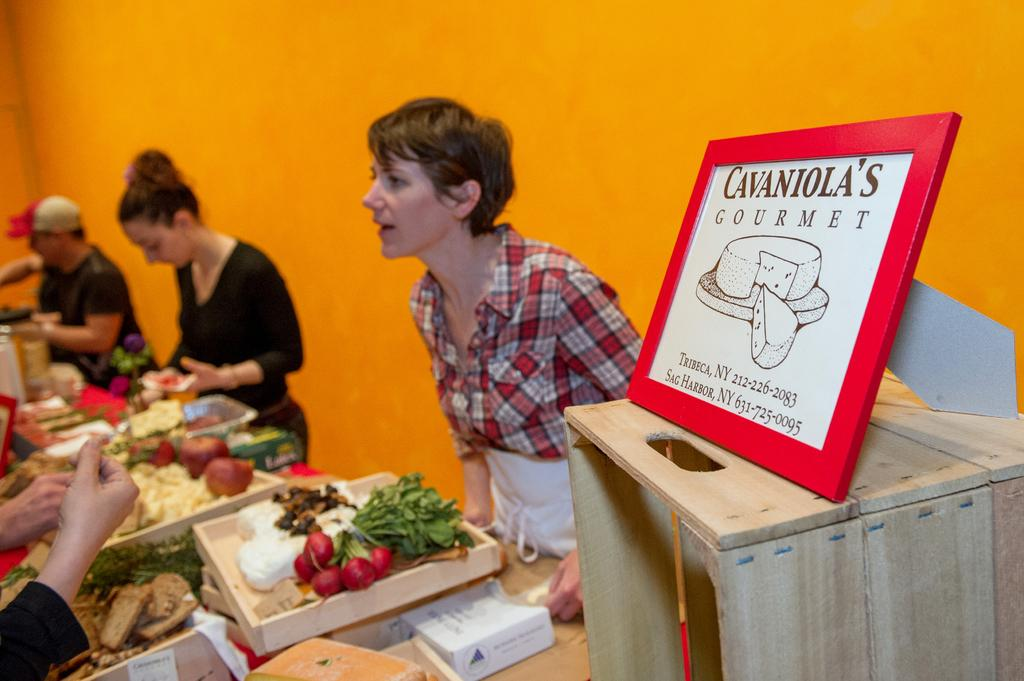What is placed on top of the box in the image? There is a board on a box in the image. What can be seen on the table in the image? There are many foods on trays on the table. How many people are present around the table in the image? Many people are standing around the table in the image. What color is the wall in the image? The wall is yellow in color. What type of leather trousers can be seen hanging on the wall in the image? There are no trousers, leather or otherwise, present in the image. Is there any snow visible in the image? There is no snow present in the image. 